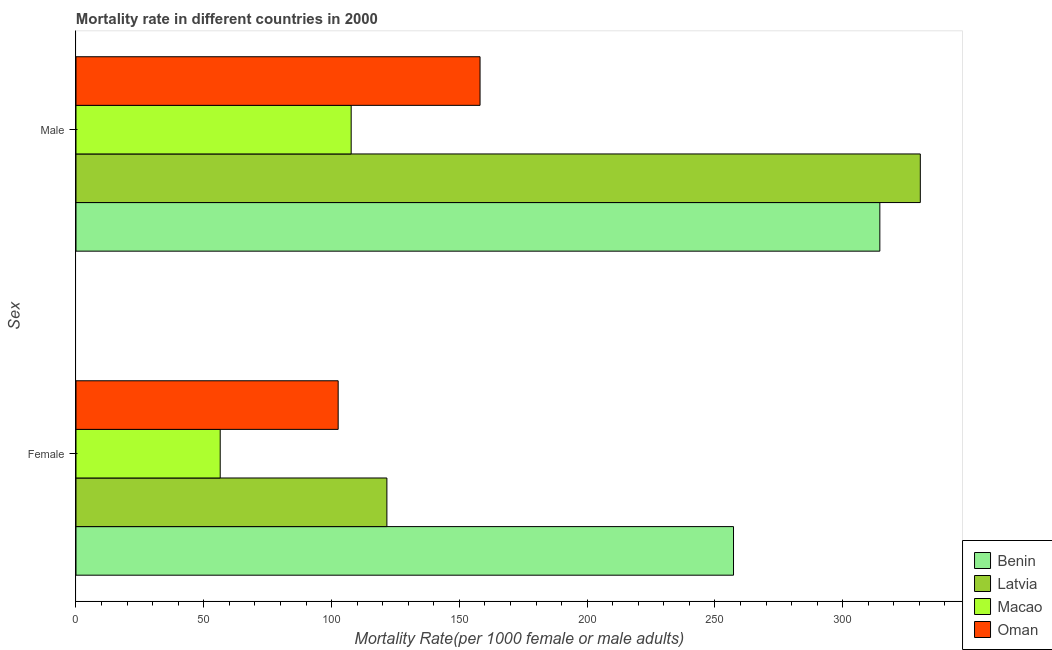How many different coloured bars are there?
Make the answer very short. 4. How many groups of bars are there?
Keep it short and to the point. 2. Are the number of bars per tick equal to the number of legend labels?
Offer a very short reply. Yes. Are the number of bars on each tick of the Y-axis equal?
Provide a short and direct response. Yes. How many bars are there on the 1st tick from the top?
Make the answer very short. 4. What is the label of the 1st group of bars from the top?
Your answer should be compact. Male. What is the male mortality rate in Macao?
Make the answer very short. 107.67. Across all countries, what is the maximum male mortality rate?
Provide a short and direct response. 330.36. Across all countries, what is the minimum female mortality rate?
Your answer should be very brief. 56.43. In which country was the female mortality rate maximum?
Your answer should be compact. Benin. In which country was the female mortality rate minimum?
Make the answer very short. Macao. What is the total male mortality rate in the graph?
Keep it short and to the point. 910.66. What is the difference between the male mortality rate in Macao and that in Benin?
Make the answer very short. -206.85. What is the difference between the female mortality rate in Benin and the male mortality rate in Oman?
Make the answer very short. 99.17. What is the average female mortality rate per country?
Make the answer very short. 134.48. What is the difference between the male mortality rate and female mortality rate in Latvia?
Provide a short and direct response. 208.71. In how many countries, is the male mortality rate greater than 130 ?
Your answer should be compact. 3. What is the ratio of the female mortality rate in Latvia to that in Oman?
Offer a very short reply. 1.19. In how many countries, is the female mortality rate greater than the average female mortality rate taken over all countries?
Keep it short and to the point. 1. What does the 1st bar from the top in Female represents?
Give a very brief answer. Oman. What does the 4th bar from the bottom in Female represents?
Ensure brevity in your answer.  Oman. How many bars are there?
Keep it short and to the point. 8. Does the graph contain grids?
Make the answer very short. No. Where does the legend appear in the graph?
Ensure brevity in your answer.  Bottom right. How many legend labels are there?
Ensure brevity in your answer.  4. What is the title of the graph?
Your answer should be very brief. Mortality rate in different countries in 2000. Does "Russian Federation" appear as one of the legend labels in the graph?
Provide a succinct answer. No. What is the label or title of the X-axis?
Your response must be concise. Mortality Rate(per 1000 female or male adults). What is the label or title of the Y-axis?
Give a very brief answer. Sex. What is the Mortality Rate(per 1000 female or male adults) in Benin in Female?
Provide a succinct answer. 257.27. What is the Mortality Rate(per 1000 female or male adults) in Latvia in Female?
Your answer should be very brief. 121.65. What is the Mortality Rate(per 1000 female or male adults) in Macao in Female?
Ensure brevity in your answer.  56.43. What is the Mortality Rate(per 1000 female or male adults) in Oman in Female?
Keep it short and to the point. 102.59. What is the Mortality Rate(per 1000 female or male adults) of Benin in Male?
Keep it short and to the point. 314.52. What is the Mortality Rate(per 1000 female or male adults) in Latvia in Male?
Provide a short and direct response. 330.36. What is the Mortality Rate(per 1000 female or male adults) in Macao in Male?
Provide a short and direct response. 107.67. What is the Mortality Rate(per 1000 female or male adults) of Oman in Male?
Provide a short and direct response. 158.1. Across all Sex, what is the maximum Mortality Rate(per 1000 female or male adults) of Benin?
Give a very brief answer. 314.52. Across all Sex, what is the maximum Mortality Rate(per 1000 female or male adults) in Latvia?
Your answer should be compact. 330.36. Across all Sex, what is the maximum Mortality Rate(per 1000 female or male adults) of Macao?
Your response must be concise. 107.67. Across all Sex, what is the maximum Mortality Rate(per 1000 female or male adults) in Oman?
Keep it short and to the point. 158.1. Across all Sex, what is the minimum Mortality Rate(per 1000 female or male adults) of Benin?
Your response must be concise. 257.27. Across all Sex, what is the minimum Mortality Rate(per 1000 female or male adults) of Latvia?
Provide a short and direct response. 121.65. Across all Sex, what is the minimum Mortality Rate(per 1000 female or male adults) in Macao?
Provide a succinct answer. 56.43. Across all Sex, what is the minimum Mortality Rate(per 1000 female or male adults) in Oman?
Provide a succinct answer. 102.59. What is the total Mortality Rate(per 1000 female or male adults) in Benin in the graph?
Provide a short and direct response. 571.8. What is the total Mortality Rate(per 1000 female or male adults) of Latvia in the graph?
Your response must be concise. 452.01. What is the total Mortality Rate(per 1000 female or male adults) of Macao in the graph?
Make the answer very short. 164.1. What is the total Mortality Rate(per 1000 female or male adults) in Oman in the graph?
Your answer should be compact. 260.69. What is the difference between the Mortality Rate(per 1000 female or male adults) in Benin in Female and that in Male?
Offer a very short reply. -57.25. What is the difference between the Mortality Rate(per 1000 female or male adults) in Latvia in Female and that in Male?
Offer a very short reply. -208.71. What is the difference between the Mortality Rate(per 1000 female or male adults) in Macao in Female and that in Male?
Provide a short and direct response. -51.25. What is the difference between the Mortality Rate(per 1000 female or male adults) in Oman in Female and that in Male?
Your answer should be compact. -55.51. What is the difference between the Mortality Rate(per 1000 female or male adults) of Benin in Female and the Mortality Rate(per 1000 female or male adults) of Latvia in Male?
Offer a very short reply. -73.09. What is the difference between the Mortality Rate(per 1000 female or male adults) in Benin in Female and the Mortality Rate(per 1000 female or male adults) in Macao in Male?
Offer a terse response. 149.6. What is the difference between the Mortality Rate(per 1000 female or male adults) in Benin in Female and the Mortality Rate(per 1000 female or male adults) in Oman in Male?
Provide a short and direct response. 99.17. What is the difference between the Mortality Rate(per 1000 female or male adults) of Latvia in Female and the Mortality Rate(per 1000 female or male adults) of Macao in Male?
Offer a terse response. 13.97. What is the difference between the Mortality Rate(per 1000 female or male adults) in Latvia in Female and the Mortality Rate(per 1000 female or male adults) in Oman in Male?
Your response must be concise. -36.45. What is the difference between the Mortality Rate(per 1000 female or male adults) of Macao in Female and the Mortality Rate(per 1000 female or male adults) of Oman in Male?
Keep it short and to the point. -101.67. What is the average Mortality Rate(per 1000 female or male adults) of Benin per Sex?
Your answer should be very brief. 285.9. What is the average Mortality Rate(per 1000 female or male adults) of Latvia per Sex?
Provide a succinct answer. 226. What is the average Mortality Rate(per 1000 female or male adults) in Macao per Sex?
Your answer should be very brief. 82.05. What is the average Mortality Rate(per 1000 female or male adults) in Oman per Sex?
Keep it short and to the point. 130.34. What is the difference between the Mortality Rate(per 1000 female or male adults) of Benin and Mortality Rate(per 1000 female or male adults) of Latvia in Female?
Your response must be concise. 135.63. What is the difference between the Mortality Rate(per 1000 female or male adults) in Benin and Mortality Rate(per 1000 female or male adults) in Macao in Female?
Ensure brevity in your answer.  200.84. What is the difference between the Mortality Rate(per 1000 female or male adults) in Benin and Mortality Rate(per 1000 female or male adults) in Oman in Female?
Offer a very short reply. 154.69. What is the difference between the Mortality Rate(per 1000 female or male adults) of Latvia and Mortality Rate(per 1000 female or male adults) of Macao in Female?
Give a very brief answer. 65.22. What is the difference between the Mortality Rate(per 1000 female or male adults) of Latvia and Mortality Rate(per 1000 female or male adults) of Oman in Female?
Give a very brief answer. 19.06. What is the difference between the Mortality Rate(per 1000 female or male adults) in Macao and Mortality Rate(per 1000 female or male adults) in Oman in Female?
Ensure brevity in your answer.  -46.16. What is the difference between the Mortality Rate(per 1000 female or male adults) of Benin and Mortality Rate(per 1000 female or male adults) of Latvia in Male?
Ensure brevity in your answer.  -15.84. What is the difference between the Mortality Rate(per 1000 female or male adults) in Benin and Mortality Rate(per 1000 female or male adults) in Macao in Male?
Your answer should be very brief. 206.85. What is the difference between the Mortality Rate(per 1000 female or male adults) in Benin and Mortality Rate(per 1000 female or male adults) in Oman in Male?
Your answer should be compact. 156.43. What is the difference between the Mortality Rate(per 1000 female or male adults) of Latvia and Mortality Rate(per 1000 female or male adults) of Macao in Male?
Your response must be concise. 222.69. What is the difference between the Mortality Rate(per 1000 female or male adults) of Latvia and Mortality Rate(per 1000 female or male adults) of Oman in Male?
Keep it short and to the point. 172.26. What is the difference between the Mortality Rate(per 1000 female or male adults) of Macao and Mortality Rate(per 1000 female or male adults) of Oman in Male?
Your response must be concise. -50.43. What is the ratio of the Mortality Rate(per 1000 female or male adults) of Benin in Female to that in Male?
Ensure brevity in your answer.  0.82. What is the ratio of the Mortality Rate(per 1000 female or male adults) of Latvia in Female to that in Male?
Offer a terse response. 0.37. What is the ratio of the Mortality Rate(per 1000 female or male adults) in Macao in Female to that in Male?
Your response must be concise. 0.52. What is the ratio of the Mortality Rate(per 1000 female or male adults) in Oman in Female to that in Male?
Your response must be concise. 0.65. What is the difference between the highest and the second highest Mortality Rate(per 1000 female or male adults) of Benin?
Offer a very short reply. 57.25. What is the difference between the highest and the second highest Mortality Rate(per 1000 female or male adults) in Latvia?
Your answer should be compact. 208.71. What is the difference between the highest and the second highest Mortality Rate(per 1000 female or male adults) of Macao?
Provide a succinct answer. 51.25. What is the difference between the highest and the second highest Mortality Rate(per 1000 female or male adults) of Oman?
Give a very brief answer. 55.51. What is the difference between the highest and the lowest Mortality Rate(per 1000 female or male adults) of Benin?
Your response must be concise. 57.25. What is the difference between the highest and the lowest Mortality Rate(per 1000 female or male adults) of Latvia?
Your answer should be compact. 208.71. What is the difference between the highest and the lowest Mortality Rate(per 1000 female or male adults) in Macao?
Your response must be concise. 51.25. What is the difference between the highest and the lowest Mortality Rate(per 1000 female or male adults) in Oman?
Make the answer very short. 55.51. 